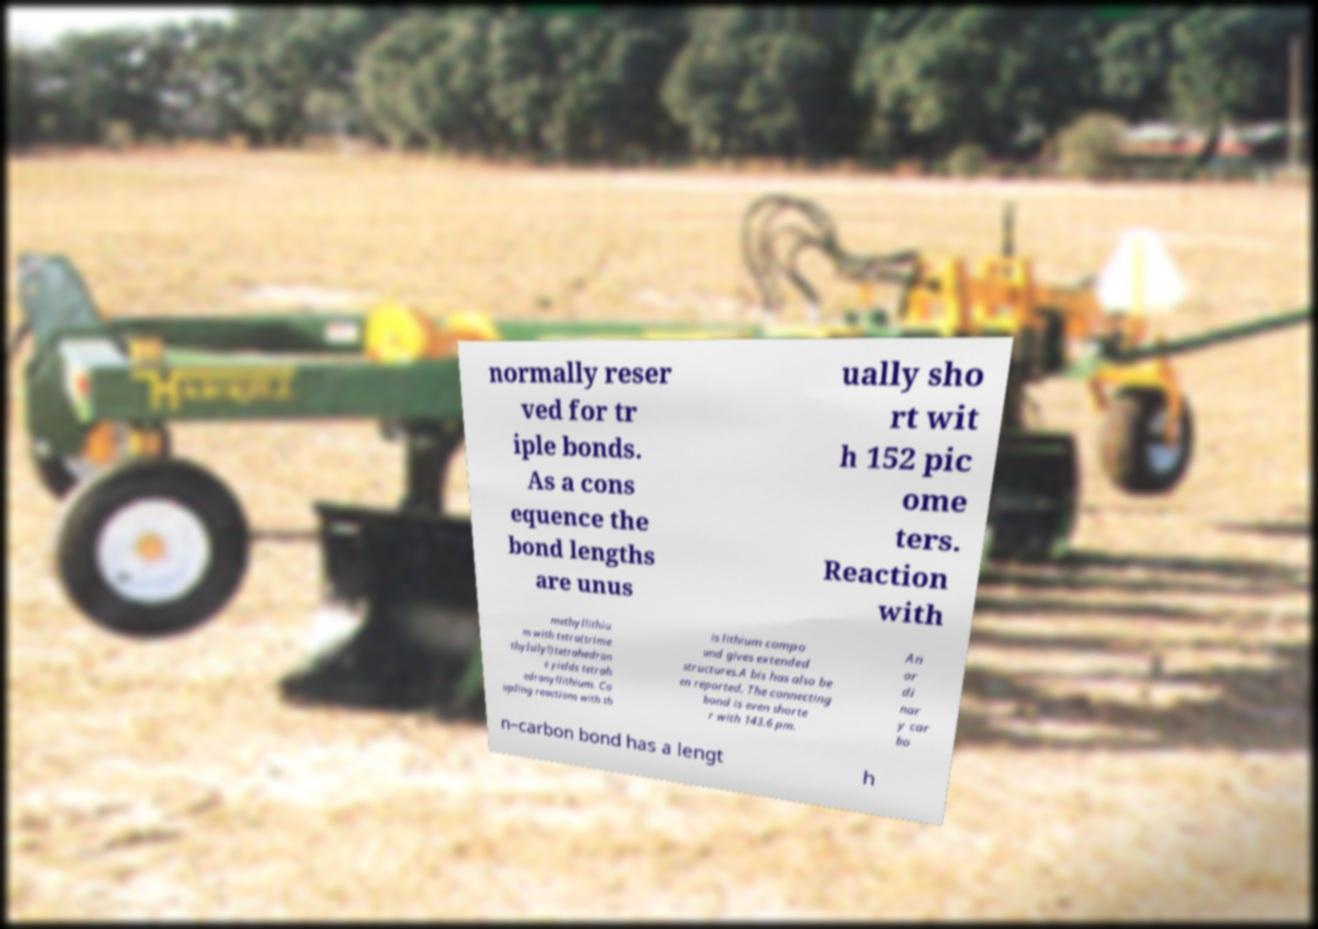Please identify and transcribe the text found in this image. normally reser ved for tr iple bonds. As a cons equence the bond lengths are unus ually sho rt wit h 152 pic ome ters. Reaction with methyllithiu m with tetra(trime thylsilyl)tetrahedran e yields tetrah edranyllithium. Co upling reactions with th is lithium compo und gives extended structures.A bis has also be en reported. The connecting bond is even shorte r with 143.6 pm. An or di nar y car bo n–carbon bond has a lengt h 